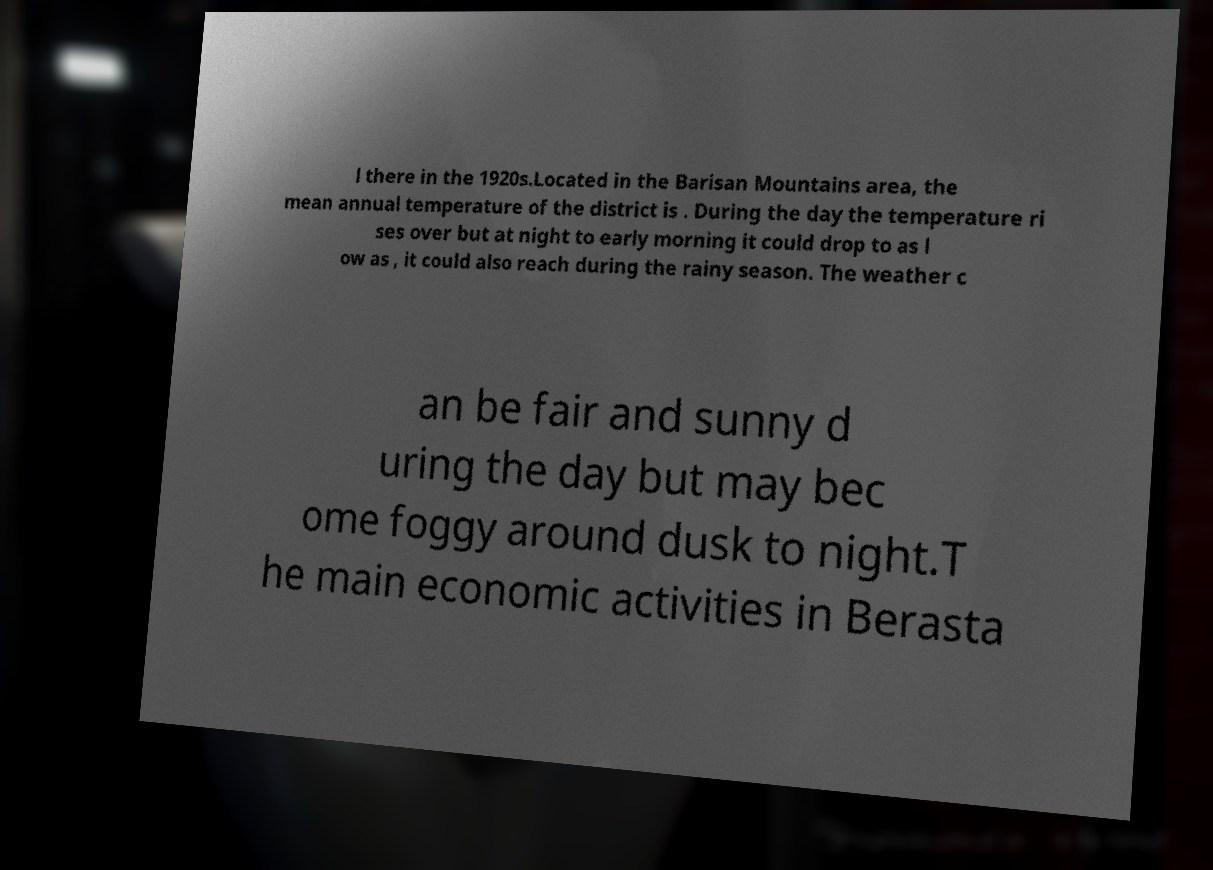Can you accurately transcribe the text from the provided image for me? l there in the 1920s.Located in the Barisan Mountains area, the mean annual temperature of the district is . During the day the temperature ri ses over but at night to early morning it could drop to as l ow as , it could also reach during the rainy season. The weather c an be fair and sunny d uring the day but may bec ome foggy around dusk to night.T he main economic activities in Berasta 